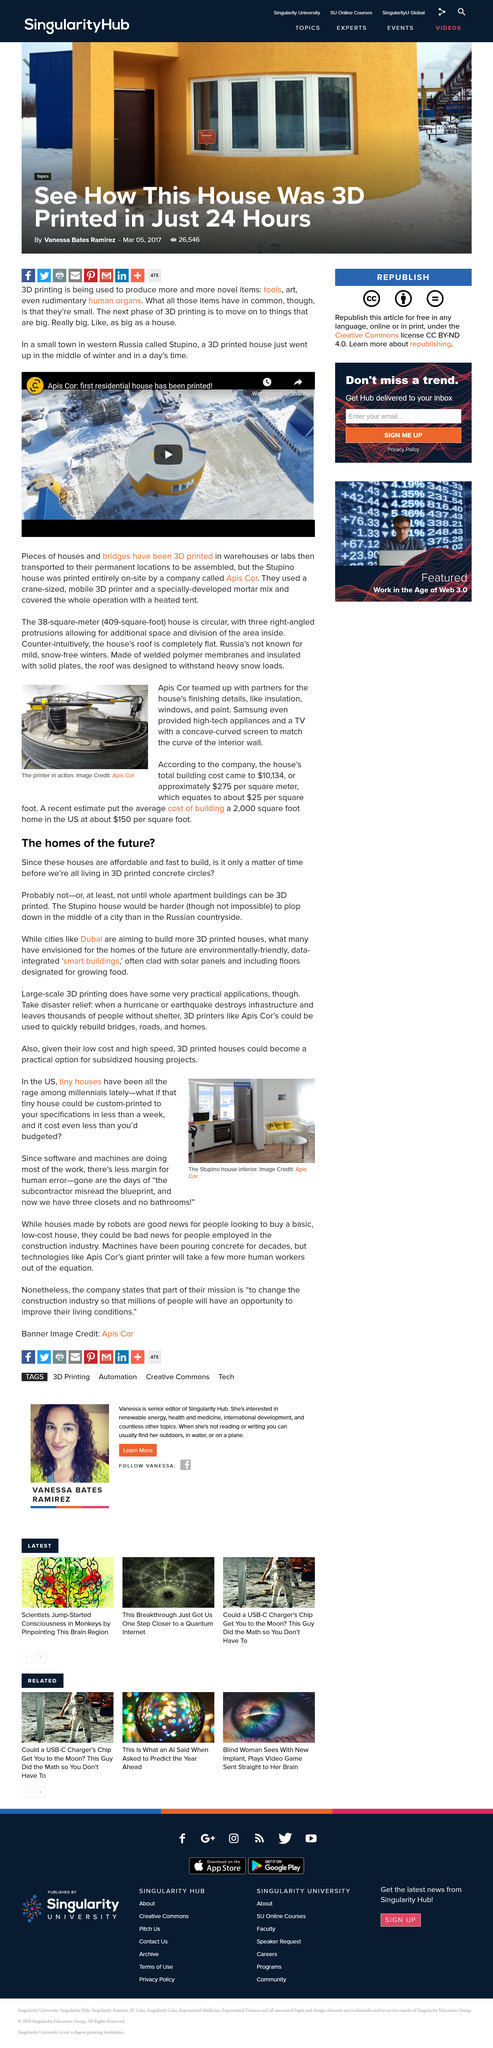Point out several critical features in this image. Dubai is aiming to build more 3D printed houses, making it the city that is striving to realize the homes of the future, as stated in the article "The homes of the future?". Large-scale 3D printing has practical applications that are undeniable. The image credit for the photo belongs to Apis Cor. The caption indicates that the photo depicts a printer in operation. The use of software and machines in various tasks has led to a reduction in the margin for human error because these tools are often more reliable and efficient than human workers. 